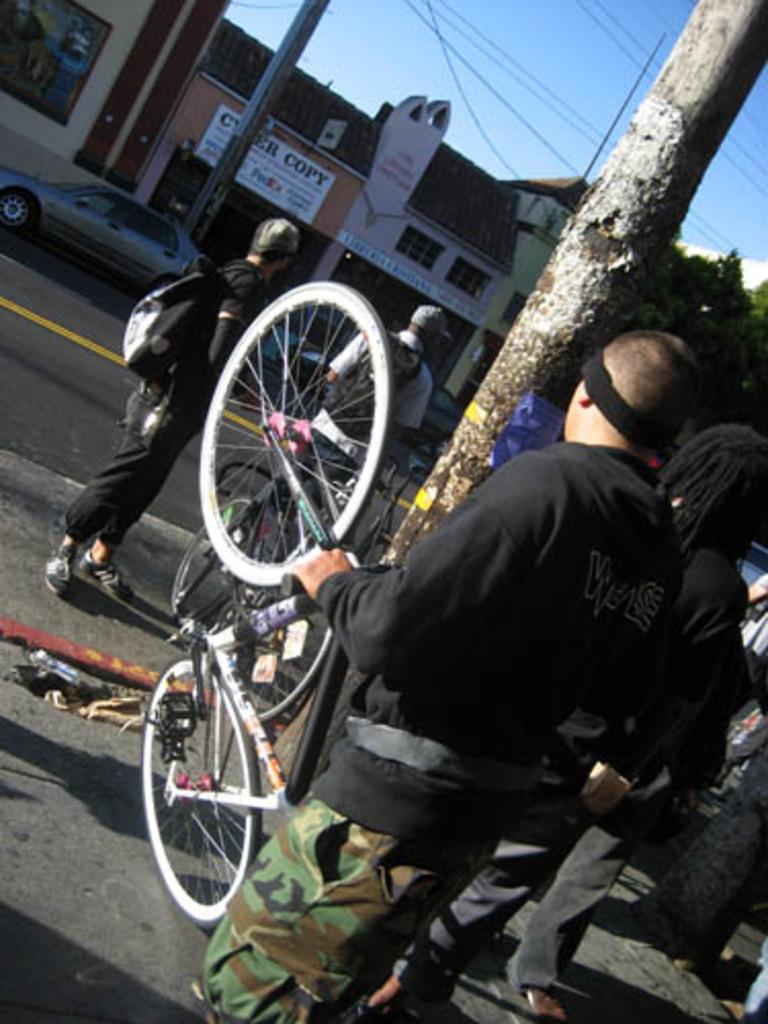In one or two sentences, can you explain what this image depicts? This image consists of few persons standing on the road. In the front, there is a man wearing black dress. He is holding a bicycle. In the background, we can see buildings and a car. At the top, there is sky. On the right, there is a tree. At the bottom, there is a road. 